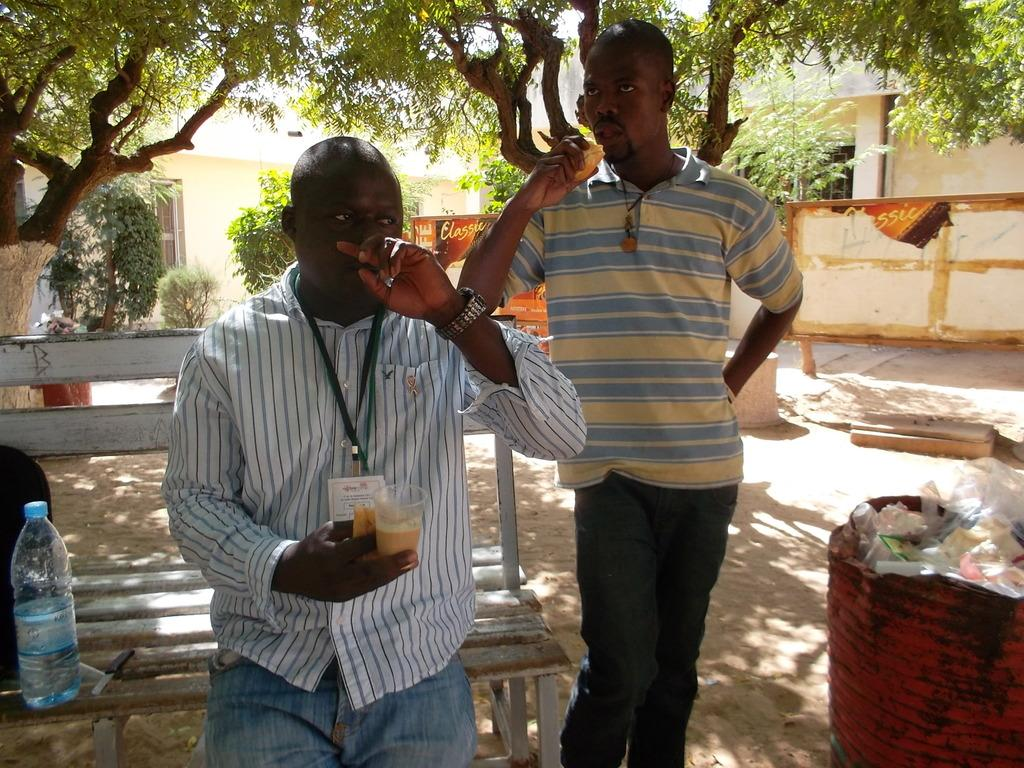How many people are in the image? There are two persons in the image. What is the man holding in the image? The man is holding a glass. What objects can be seen on the bench in the image? There is a water bottle and a knife on the bench in the image. What can be seen in the background of the image? There is a building and trees in the background of the image. What type of mitten is the man wearing in the image? There is no mitten present in the image; the man is not wearing any gloves or mittens. What agreement was reached between the two persons in the image? There is no indication of any agreement or discussion between the two persons in the image. 